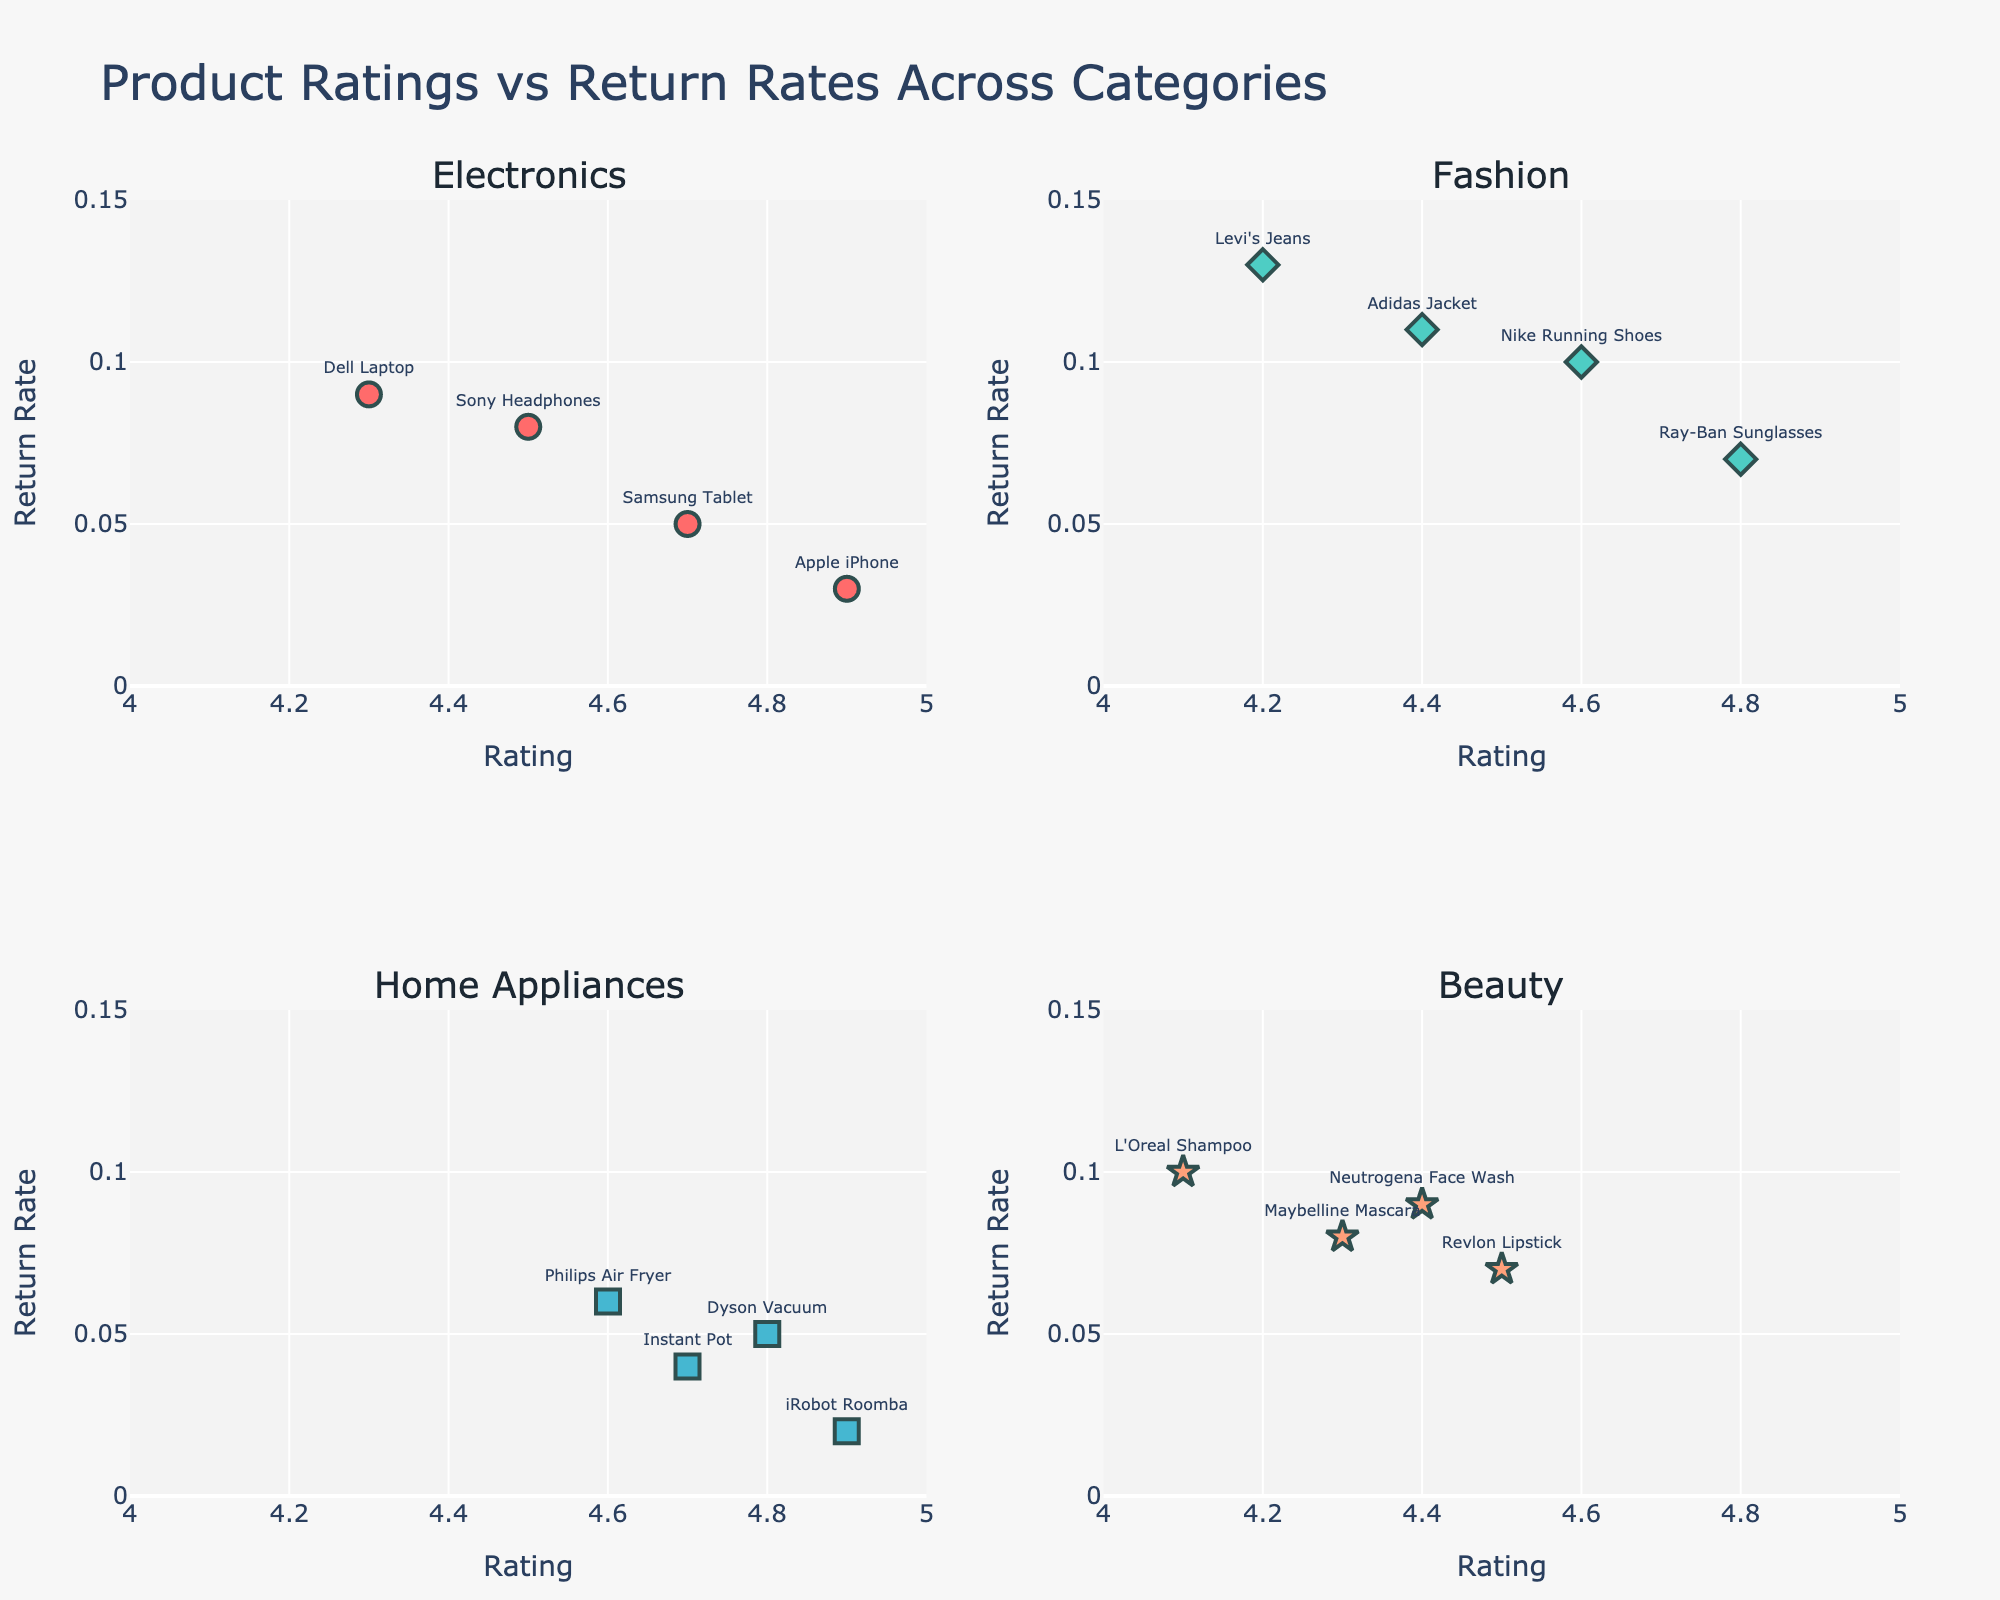How many categories are represented in the figure? The figure has subplot titles representing each category of products. By counting the unique subplot titles, we can determine the number of categories.
Answer: 4 What is the highest product rating among Electronics? By locating the Electronics subplot and identifying the highest x-axis value, which represents the rating, we can find the highest rating.
Answer: 4.9 Which category has the highest overall return rate observed? We need to locate the highest y-axis value across all subplots. Each subplot represents a category, so the subplot with the highest y-value will give us the category.
Answer: Fashion Are there more data points in the Electronics category or the Beauty category? By comparing the number of markers (data points) in the subplots for Electronics and Beauty, we can count to see which has more.
Answer: Electronics Which product has the lowest return rate in the Home Appliances category? Locate the Home Appliances subplot and identify the point with the lowest y-value, then check the associated product text.
Answer: iRobot Roomba What is the average return rate for products in the Fashion category? Sum the return rates for all Fashion products and then divide by the number of Fashion products. The return rates are 0.10, 0.11, 0.13, and 0.07, so (0.10 + 0.11 + 0.13 + 0.07) / 4 = 0.1025.
Answer: 0.1025 Do Home Appliances generally have higher ratings than Beauty products? Compare the x-axis values (ratings) of the markers in the Home Appliances and Beauty subplots to see which category generally has higher ratings.
Answer: Yes Which product has the closest return rate to 0.05 in the Electronics category? Locate the Electronics subplot and identify the point closest to a y-axis value of 0.05, then check the associated product text.
Answer: Samsung Tablet Is there a strong correlation between product ratings and return rates in any of the categories? By observing the correlation (how clustered or spread out the points are) in each subplot, we can infer if there is a strong relationship between ratings and return rates.
Answer: No Which category has the best overall ratings? Compare the clustering of x-axis values (higher ratings) across all subplots to see which one has more markers closer to a rating of 5.
Answer: Electronics 